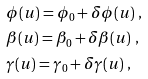<formula> <loc_0><loc_0><loc_500><loc_500>& \phi ( u ) = \phi _ { 0 } + \delta \phi ( u ) \ , \\ & \beta ( u ) = \beta _ { 0 } + \delta \beta ( u ) \ , \\ & \gamma ( u ) = \gamma _ { 0 } + \delta \gamma ( u ) \ ,</formula> 